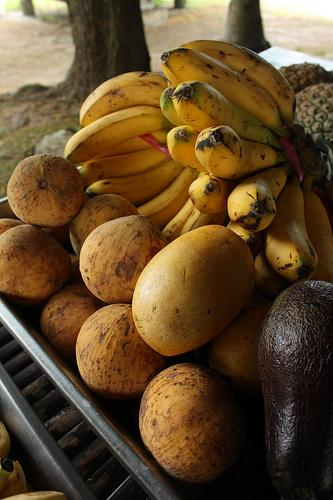Provide an overview of the containers and their contents in the image. There is a metal container filled with different produce items, such as pineapples, avocados, bananas, and coconuts. The side of the container and a white table corner are also visible in the background. What is the special identification feature of the pineapple in the image? The pineapple has a green and brown rind that distinguishes it in the pile of fruits. Point out some noticeable details about the bananas in the image. The bananas are ripe and yellow, with some of them showing black spots, black button ends, and red strings around the bunches. Estimate how many coconuts are there in the image. There appears to be a pile of coconuts and a fresh tan coconut, resulting in a group of more than two coconuts in the image. Describe the organization of the fruits in the image. The fruits are presented in piles, in bins, and on a white table, with some of them scattered around and also lying on top of each other. Describe the scene involving a tree trunk and environment elements in the image. There is no tree trunk or environment elements like a dirt road or forest visible in the image. The focus is solely on the fruits displayed on a metal container. Explain how the bananas in the image are secured. There's red string or tape wrapping around several bunches of ripe bananas, securing them together. Using the information provided, describe the image sentiment, and explain why. The image sentiment is joyful since it showcases various fresh, colorful tropical fruits that may evoke happy feelings related to healthy eating and summer vibes. Identify and provide a brief description of the types of fruit present in the image. There are coconuts, ripe avocados, yellow bananas with black spots, round tan fruits, pineapples, and dark purple avocados in the image. 